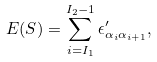<formula> <loc_0><loc_0><loc_500><loc_500>E ( S ) = \sum _ { i = I _ { 1 } } ^ { I _ { 2 } - 1 } \epsilon ^ { \prime } _ { \alpha _ { i } \alpha _ { i + 1 } } ,</formula> 